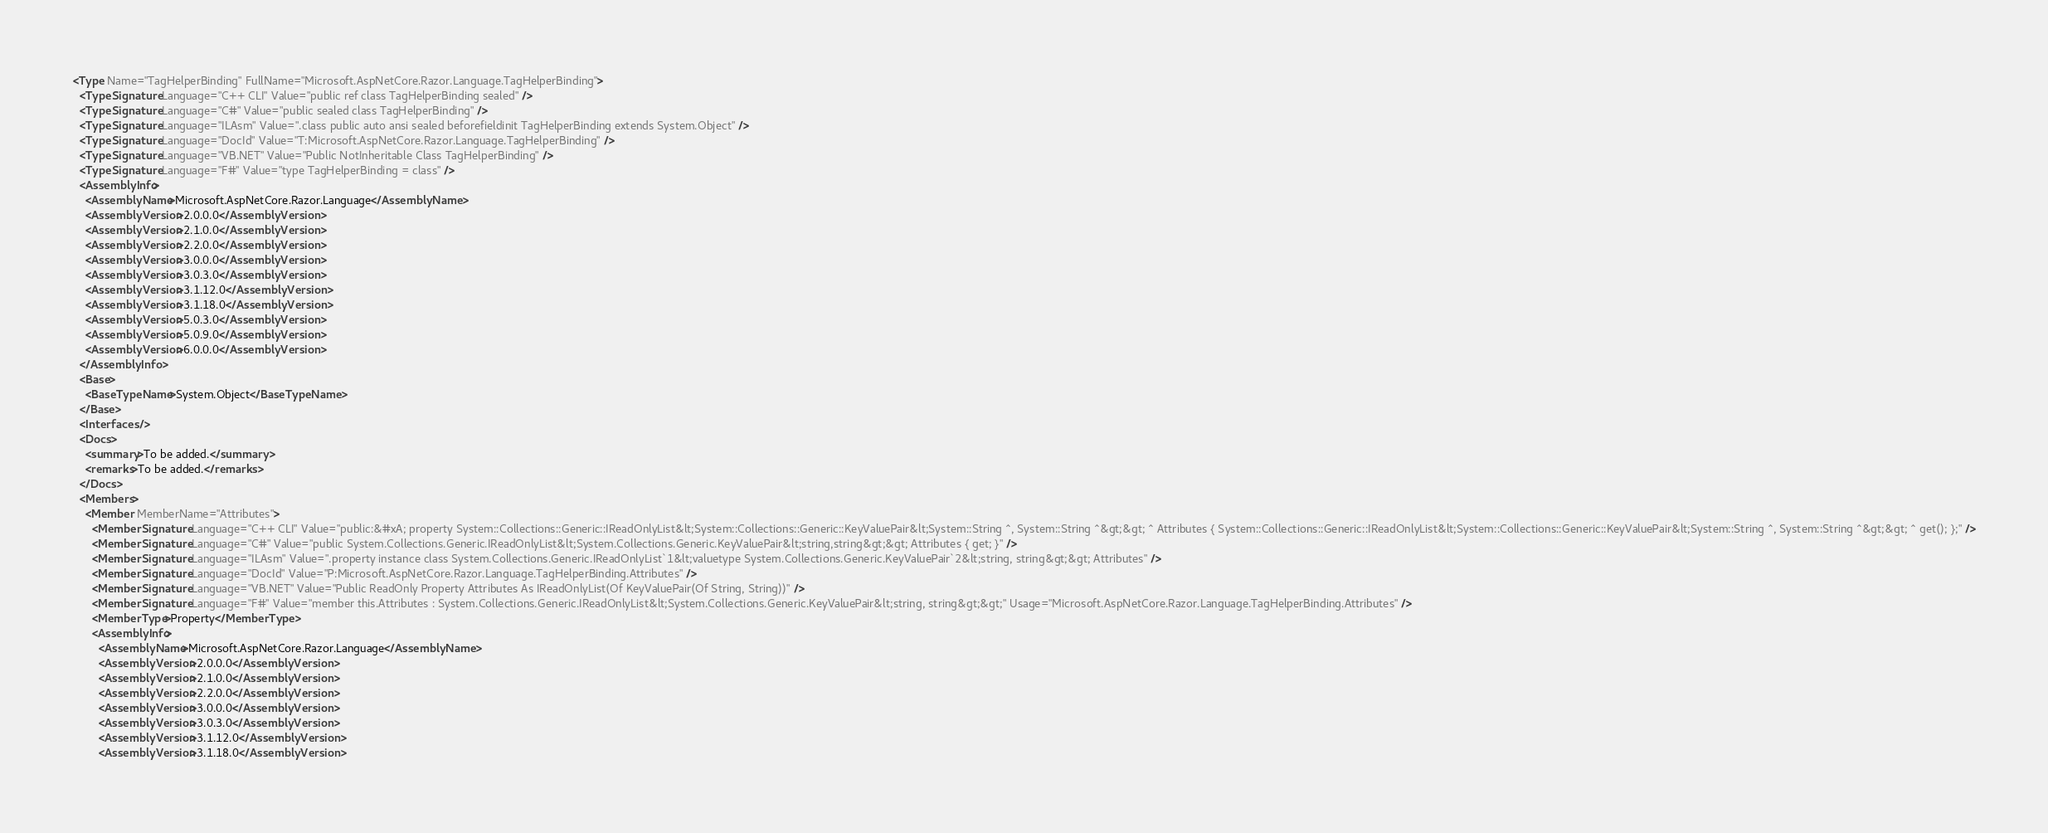Convert code to text. <code><loc_0><loc_0><loc_500><loc_500><_XML_><Type Name="TagHelperBinding" FullName="Microsoft.AspNetCore.Razor.Language.TagHelperBinding">
  <TypeSignature Language="C++ CLI" Value="public ref class TagHelperBinding sealed" />
  <TypeSignature Language="C#" Value="public sealed class TagHelperBinding" />
  <TypeSignature Language="ILAsm" Value=".class public auto ansi sealed beforefieldinit TagHelperBinding extends System.Object" />
  <TypeSignature Language="DocId" Value="T:Microsoft.AspNetCore.Razor.Language.TagHelperBinding" />
  <TypeSignature Language="VB.NET" Value="Public NotInheritable Class TagHelperBinding" />
  <TypeSignature Language="F#" Value="type TagHelperBinding = class" />
  <AssemblyInfo>
    <AssemblyName>Microsoft.AspNetCore.Razor.Language</AssemblyName>
    <AssemblyVersion>2.0.0.0</AssemblyVersion>
    <AssemblyVersion>2.1.0.0</AssemblyVersion>
    <AssemblyVersion>2.2.0.0</AssemblyVersion>
    <AssemblyVersion>3.0.0.0</AssemblyVersion>
    <AssemblyVersion>3.0.3.0</AssemblyVersion>
    <AssemblyVersion>3.1.12.0</AssemblyVersion>
    <AssemblyVersion>3.1.18.0</AssemblyVersion>
    <AssemblyVersion>5.0.3.0</AssemblyVersion>
    <AssemblyVersion>5.0.9.0</AssemblyVersion>
    <AssemblyVersion>6.0.0.0</AssemblyVersion>
  </AssemblyInfo>
  <Base>
    <BaseTypeName>System.Object</BaseTypeName>
  </Base>
  <Interfaces />
  <Docs>
    <summary>To be added.</summary>
    <remarks>To be added.</remarks>
  </Docs>
  <Members>
    <Member MemberName="Attributes">
      <MemberSignature Language="C++ CLI" Value="public:&#xA; property System::Collections::Generic::IReadOnlyList&lt;System::Collections::Generic::KeyValuePair&lt;System::String ^, System::String ^&gt;&gt; ^ Attributes { System::Collections::Generic::IReadOnlyList&lt;System::Collections::Generic::KeyValuePair&lt;System::String ^, System::String ^&gt;&gt; ^ get(); };" />
      <MemberSignature Language="C#" Value="public System.Collections.Generic.IReadOnlyList&lt;System.Collections.Generic.KeyValuePair&lt;string,string&gt;&gt; Attributes { get; }" />
      <MemberSignature Language="ILAsm" Value=".property instance class System.Collections.Generic.IReadOnlyList`1&lt;valuetype System.Collections.Generic.KeyValuePair`2&lt;string, string&gt;&gt; Attributes" />
      <MemberSignature Language="DocId" Value="P:Microsoft.AspNetCore.Razor.Language.TagHelperBinding.Attributes" />
      <MemberSignature Language="VB.NET" Value="Public ReadOnly Property Attributes As IReadOnlyList(Of KeyValuePair(Of String, String))" />
      <MemberSignature Language="F#" Value="member this.Attributes : System.Collections.Generic.IReadOnlyList&lt;System.Collections.Generic.KeyValuePair&lt;string, string&gt;&gt;" Usage="Microsoft.AspNetCore.Razor.Language.TagHelperBinding.Attributes" />
      <MemberType>Property</MemberType>
      <AssemblyInfo>
        <AssemblyName>Microsoft.AspNetCore.Razor.Language</AssemblyName>
        <AssemblyVersion>2.0.0.0</AssemblyVersion>
        <AssemblyVersion>2.1.0.0</AssemblyVersion>
        <AssemblyVersion>2.2.0.0</AssemblyVersion>
        <AssemblyVersion>3.0.0.0</AssemblyVersion>
        <AssemblyVersion>3.0.3.0</AssemblyVersion>
        <AssemblyVersion>3.1.12.0</AssemblyVersion>
        <AssemblyVersion>3.1.18.0</AssemblyVersion></code> 